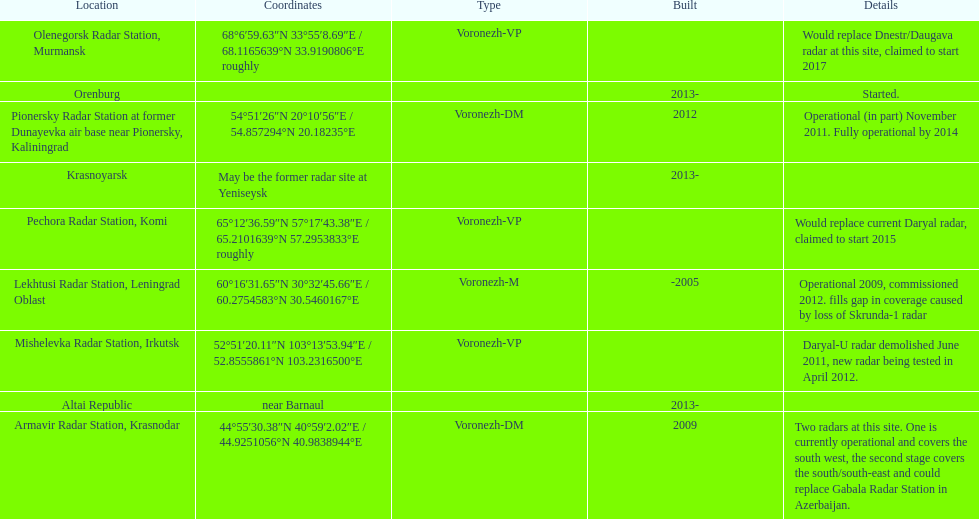What is the only radar that will start in 2015? Pechora Radar Station, Komi. 